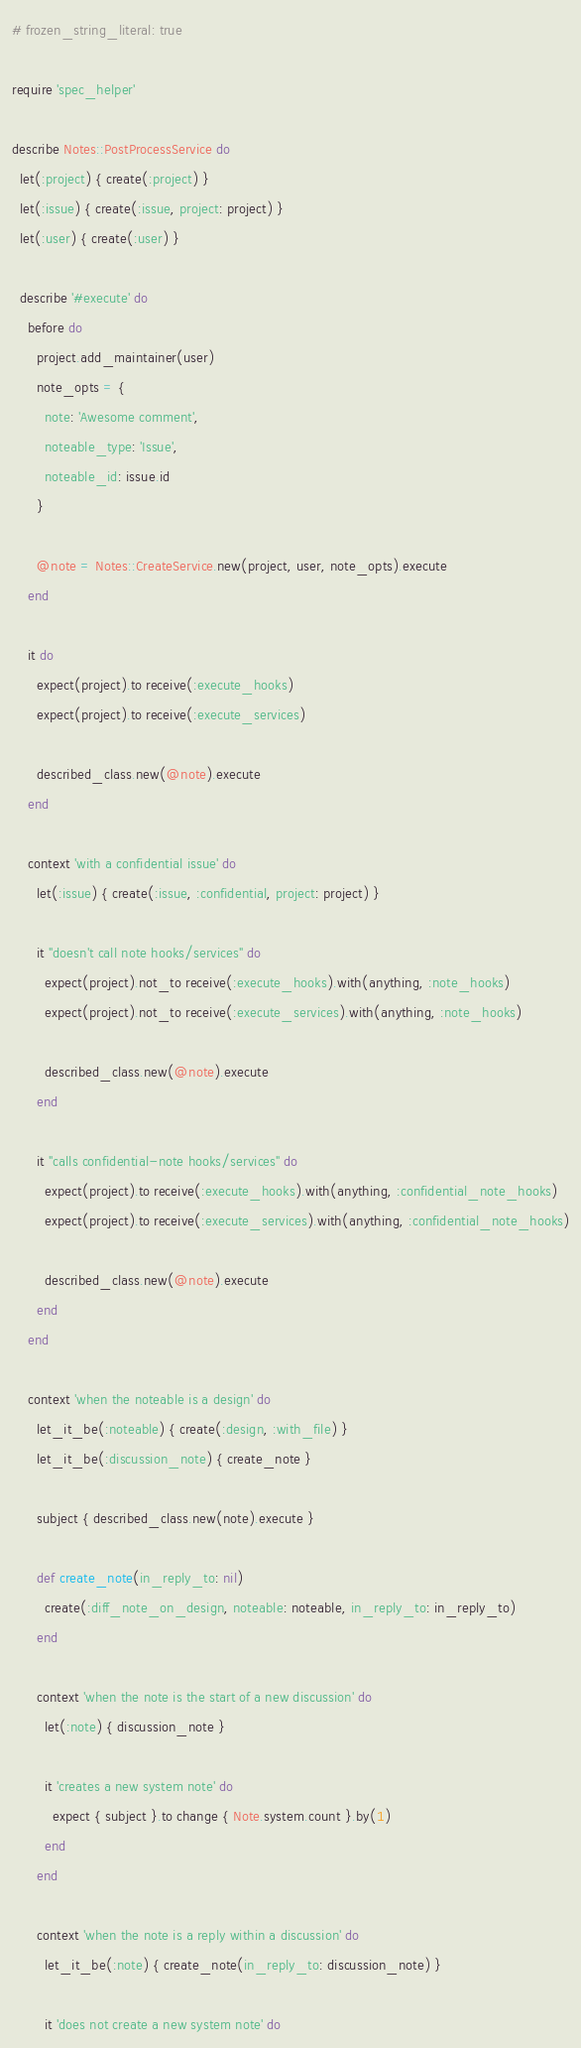Convert code to text. <code><loc_0><loc_0><loc_500><loc_500><_Ruby_># frozen_string_literal: true

require 'spec_helper'

describe Notes::PostProcessService do
  let(:project) { create(:project) }
  let(:issue) { create(:issue, project: project) }
  let(:user) { create(:user) }

  describe '#execute' do
    before do
      project.add_maintainer(user)
      note_opts = {
        note: 'Awesome comment',
        noteable_type: 'Issue',
        noteable_id: issue.id
      }

      @note = Notes::CreateService.new(project, user, note_opts).execute
    end

    it do
      expect(project).to receive(:execute_hooks)
      expect(project).to receive(:execute_services)

      described_class.new(@note).execute
    end

    context 'with a confidential issue' do
      let(:issue) { create(:issue, :confidential, project: project) }

      it "doesn't call note hooks/services" do
        expect(project).not_to receive(:execute_hooks).with(anything, :note_hooks)
        expect(project).not_to receive(:execute_services).with(anything, :note_hooks)

        described_class.new(@note).execute
      end

      it "calls confidential-note hooks/services" do
        expect(project).to receive(:execute_hooks).with(anything, :confidential_note_hooks)
        expect(project).to receive(:execute_services).with(anything, :confidential_note_hooks)

        described_class.new(@note).execute
      end
    end

    context 'when the noteable is a design' do
      let_it_be(:noteable) { create(:design, :with_file) }
      let_it_be(:discussion_note) { create_note }

      subject { described_class.new(note).execute }

      def create_note(in_reply_to: nil)
        create(:diff_note_on_design, noteable: noteable, in_reply_to: in_reply_to)
      end

      context 'when the note is the start of a new discussion' do
        let(:note) { discussion_note }

        it 'creates a new system note' do
          expect { subject }.to change { Note.system.count }.by(1)
        end
      end

      context 'when the note is a reply within a discussion' do
        let_it_be(:note) { create_note(in_reply_to: discussion_note) }

        it 'does not create a new system note' do</code> 